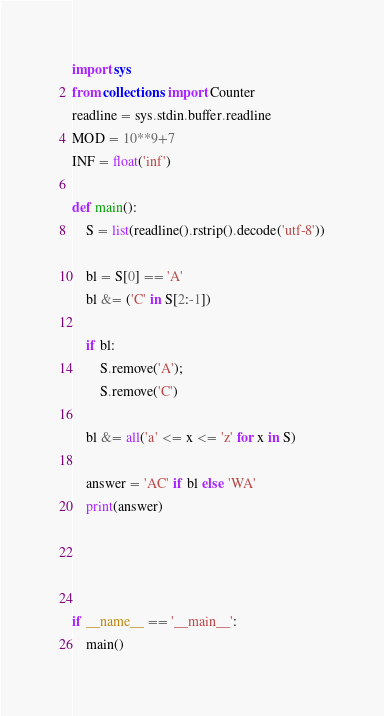<code> <loc_0><loc_0><loc_500><loc_500><_Python_>import sys
from collections import Counter
readline = sys.stdin.buffer.readline
MOD = 10**9+7
INF = float('inf')

def main():
    S = list(readline().rstrip().decode('utf-8'))

    bl = S[0] == 'A'
    bl &= ('C' in S[2:-1])

    if bl:
        S.remove('A');
        S.remove('C')

    bl &= all('a' <= x <= 'z' for x in S)

    answer = 'AC' if bl else 'WA'
    print(answer)




if __name__ == '__main__':
    main()</code> 